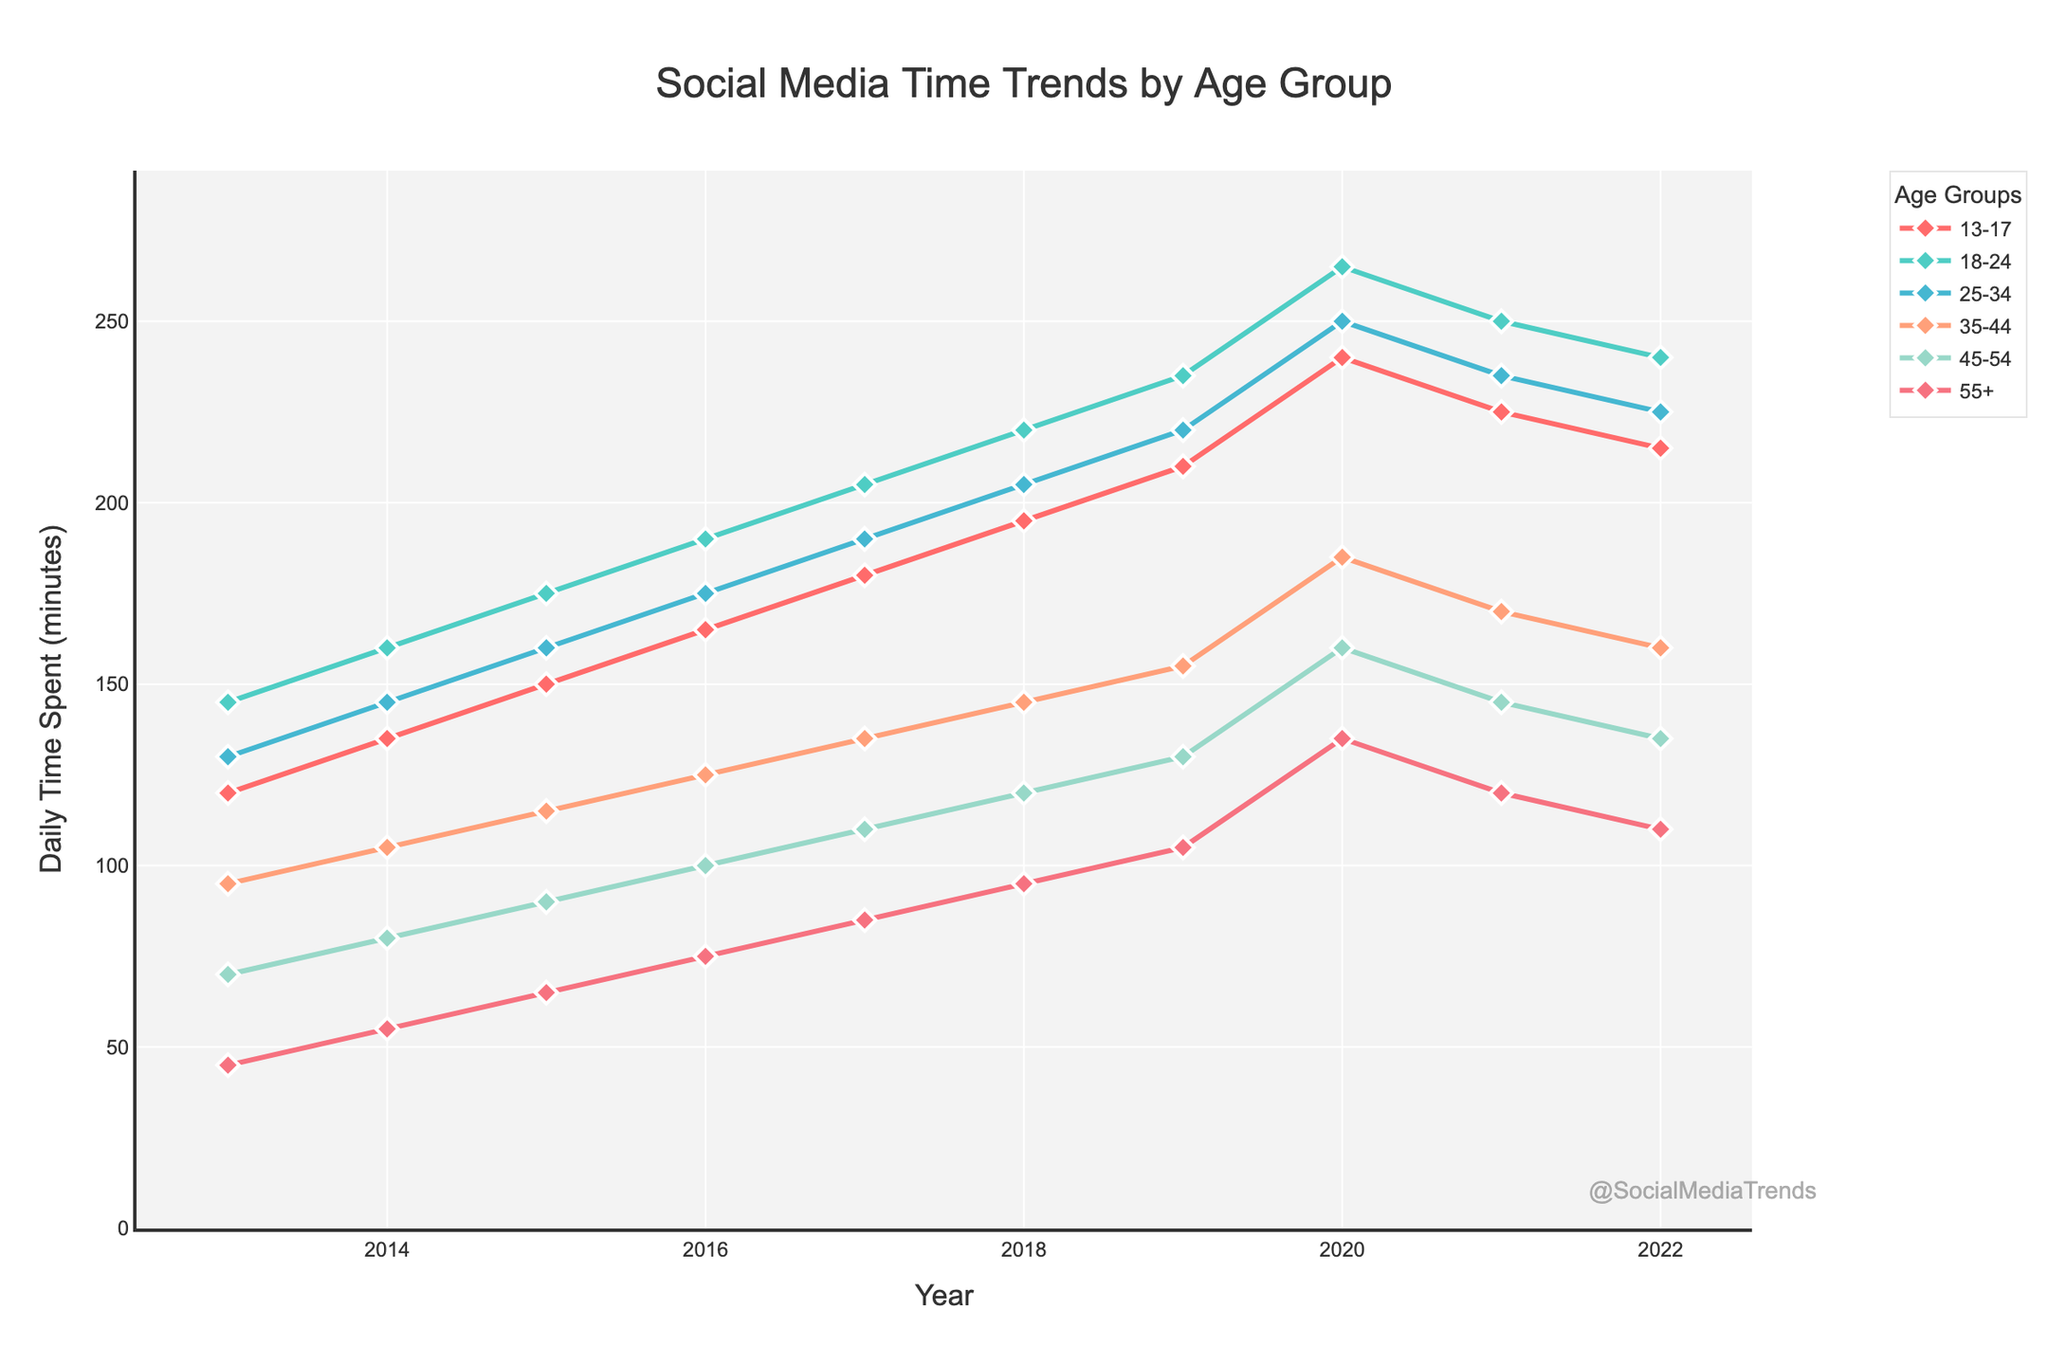what is the difference in daily time spent on social media between the 18-24 and 55+ age groups in 2020? First, find the time spent for the 18-24 and 55+ age groups in 2020 from the chart. The 18-24 age group spent 265 minutes, and the 55+ age group spent 135 minutes. The difference is 265 - 135.
Answer: 130 minutes which age group showed the most significant increase in daily social media usage from 2013 to 2020? Compare the 2013 and 2020 data for each age group: the 13-17 group increased from 120 to 240 minutes (120 minutes increase), the 18-24 from 145 to 265 (120 minutes), the 25-34 from 130 to 250 (120 minutes), the 35-44 from 95 to 185 (90 minutes), the 45-54 from 70 to 160 (90 minutes), and the 55+ from 45 to 135 (90 minutes). Each group 13-17, 18-24, and 25-34 recorded the same highest change of 120 minutes.
Answer: 13-17, 18-24, 25-34 which age group had a decrease in daily social media usage from 2021 to 2022? Identify the values for each age group from 2021 to 2022: 13-17 decreased from 225 to 215, 18-24 decreased from 250 to 240, 25-34 decreased from 235 to 225, 35-44 decreased from 170 to 160, 45-54 decreased from 145 to 135, and 55+ decreased from 120 to 110. All age groups show a decrease.
Answer: All age groups in which year did the 35-44 age group spend the same amount of time as the 55+ age group did in 2021? Locate the 55+ age group's time in 2021, which is 120 minutes. Then find this value for the 35-44 age group over the years: in 2019, the 35-44 age group spent 120 minutes.
Answer: 2019 what is the average daily time spent on social media by the 45-54 age group from 2013 to 2022? Sum the daily time values for 45-54 across the years: 70 + 80 + 90 + 100 + 110 + 120 + 130 + 160 + 145 + 135 = 1140. Then divide by the number of years (10): 1140 / 10 = 114.
Answer: 114 minutes which two age groups had the closest daily social media usage in 2022? Compare the values for all age groups in 2022: 13-17 (215), 18-24 (240), 25-34 (225), 35-44 (160), 45-54 (135), and 55+ (110). The closest values are 25-34 and 18-24 with 225 and 240, respectively, having a difference of 15 minutes.
Answer: 25-34 and 18-24 which age groups saw a peak in daily time spent on social media in 2020? Check the values for each age group from 2013 to 2022 and identify the peaks. The 18-24 (265), 25-34 (250), 35-44 (185), 45-54 (160), and 55+ (135) age groups all saw their peak in 2020.
Answer: 18-24, 25-34, 35-44, 45-54, 55+ which age group consistently increased its daily social media usage each year from 2013 to 2020? Check the yearly values for each age group: only 55+ shows a consistent increase from 2013 (45) to 2020 (135) without any drops.
Answer: 55+ what is the overall trend in daily social media usage from 2013 to 2022 across all age groups? Observe the trajectories for each age group from the chart: all age groups show an overall increase in daily social media usage from 2013 to a peak around 2020, followed by a slight decrease til 2022.
Answer: Increased till 2020, then slight decrease 